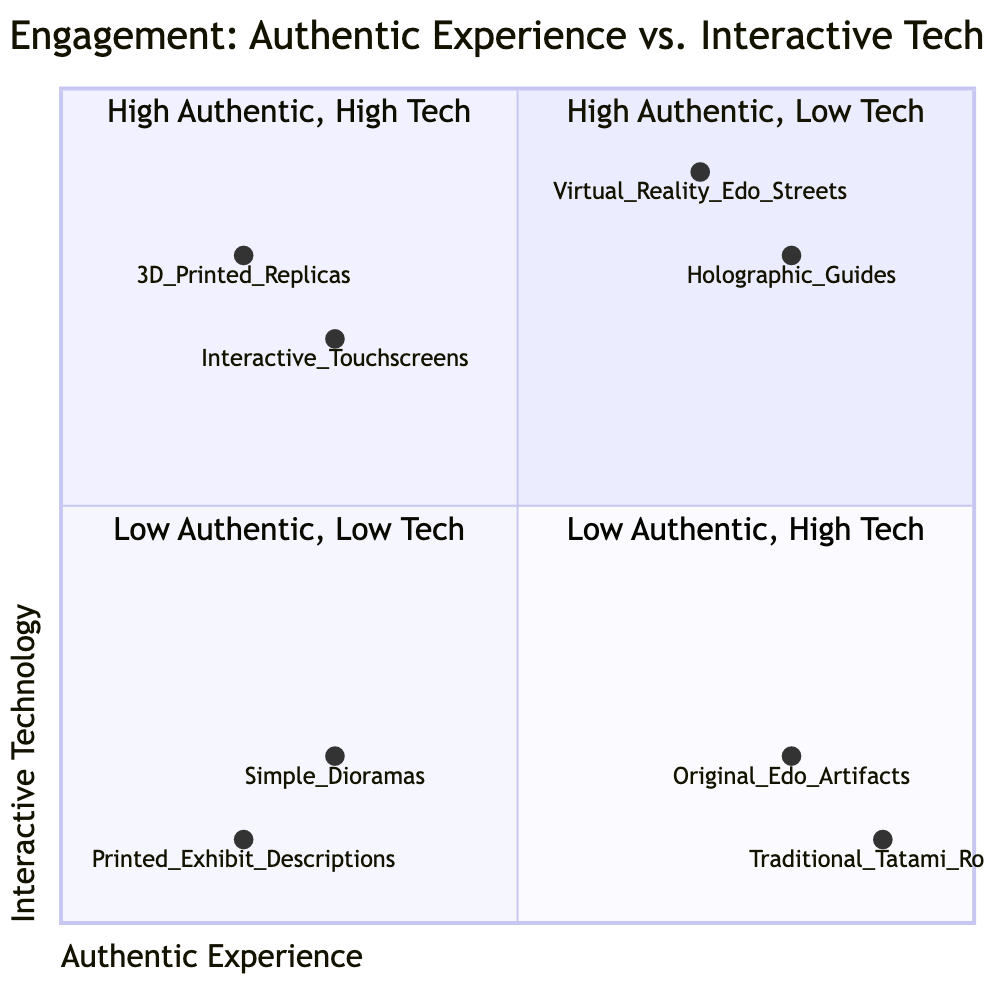What exhibits are in the top left quadrant? The top left quadrant represents high authentic experience and low interactive technology. The listed exhibits are "Original Edo Artifacts" and "Traditional Tatami Room."
Answer: Original Edo Artifacts, Traditional Tatami Room How many elements are in the bottom right quadrant? The bottom right quadrant represents low authentic experience and high interactive technology. It contains two elements: "Interactive Touchscreens" and "3D Printed Replicas."
Answer: 2 Which element is the highest in interactive technology? In the top right quadrant, "Virtual Reality Edo Streets" has the highest value for interactive technology at 0.9.
Answer: Virtual Reality Edo Streets Which quadrant contains "Printed Exhibit Descriptions"? "Printed Exhibit Descriptions" is located in the bottom left quadrant, which features low authentic experience and low interactive technology.
Answer: Bottom left What is the y-axis value of "Holographic Guides"? "Holographic Guides" is situated in the top right quadrant and has a y-axis value of 0.8 for interactive technology.
Answer: 0.8 Which quadrant has a mix of authenticity and technology? The top right quadrant includes exhibits that provide both high authentic experiences and high interactive technology, exemplified by "Virtual Reality Edo Streets" and "Holographic Guides."
Answer: Top right Which exhibit has the lowest score for authentic experience? The exhibit with the lowest score for authentic experience is "Printed Exhibit Descriptions," which has a value of 0.2.
Answer: Printed Exhibit Descriptions What is the x-axis value of "3D Printed Replicas"? "3D Printed Replicas" is located in the bottom right quadrant and has an x-axis value of 0.2 for authentic experience.
Answer: 0.2 